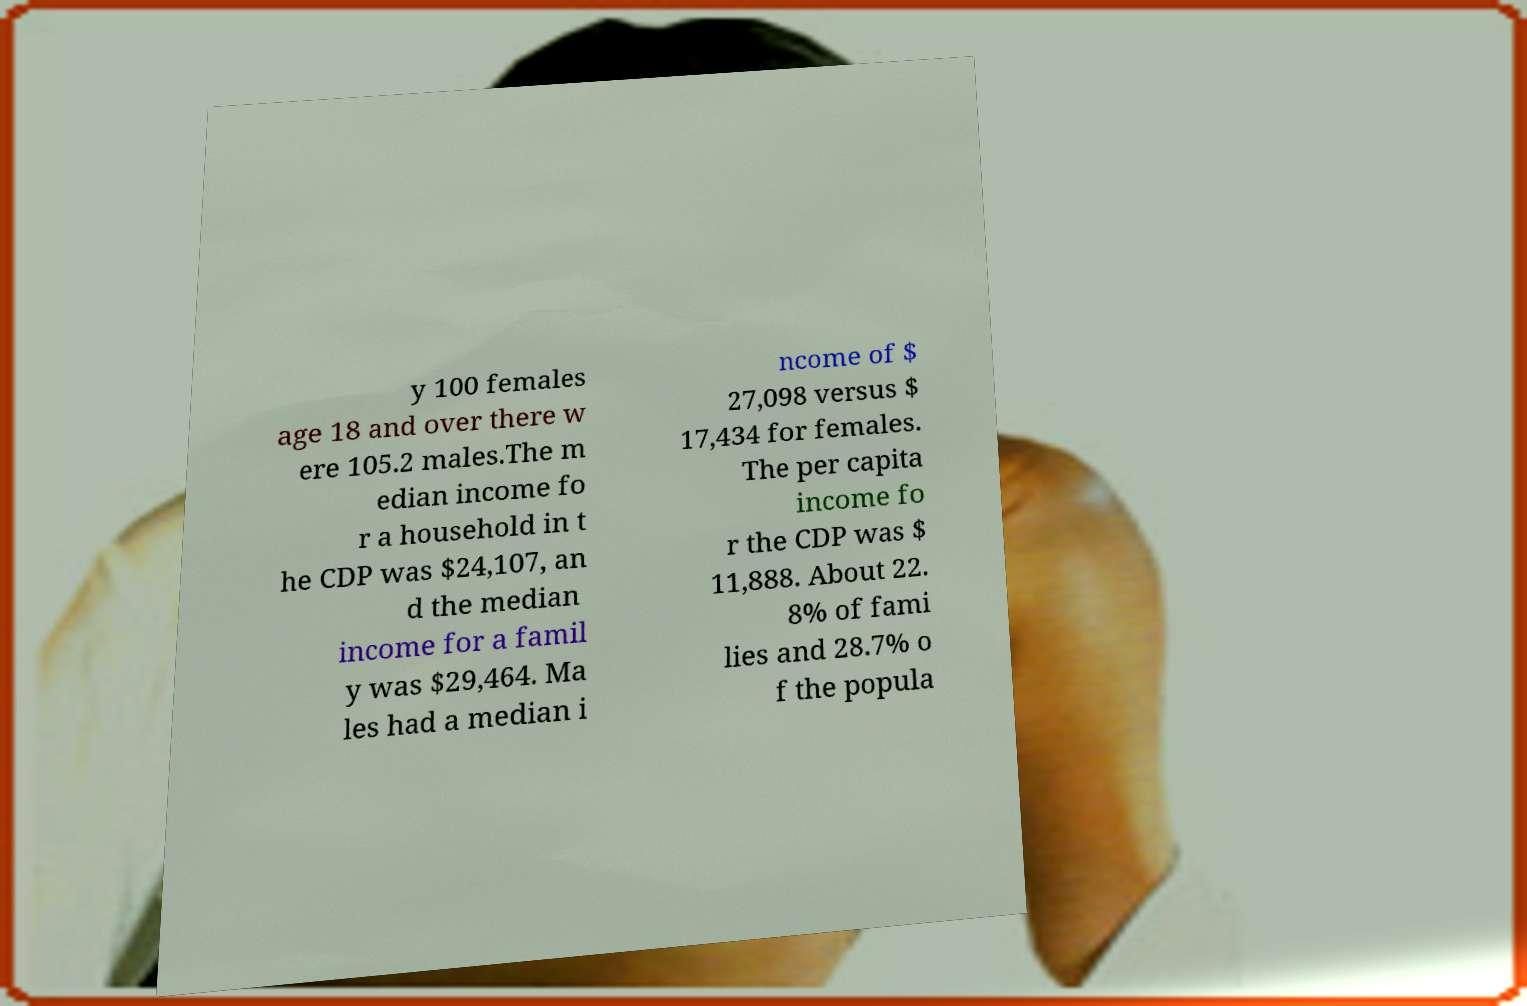I need the written content from this picture converted into text. Can you do that? y 100 females age 18 and over there w ere 105.2 males.The m edian income fo r a household in t he CDP was $24,107, an d the median income for a famil y was $29,464. Ma les had a median i ncome of $ 27,098 versus $ 17,434 for females. The per capita income fo r the CDP was $ 11,888. About 22. 8% of fami lies and 28.7% o f the popula 